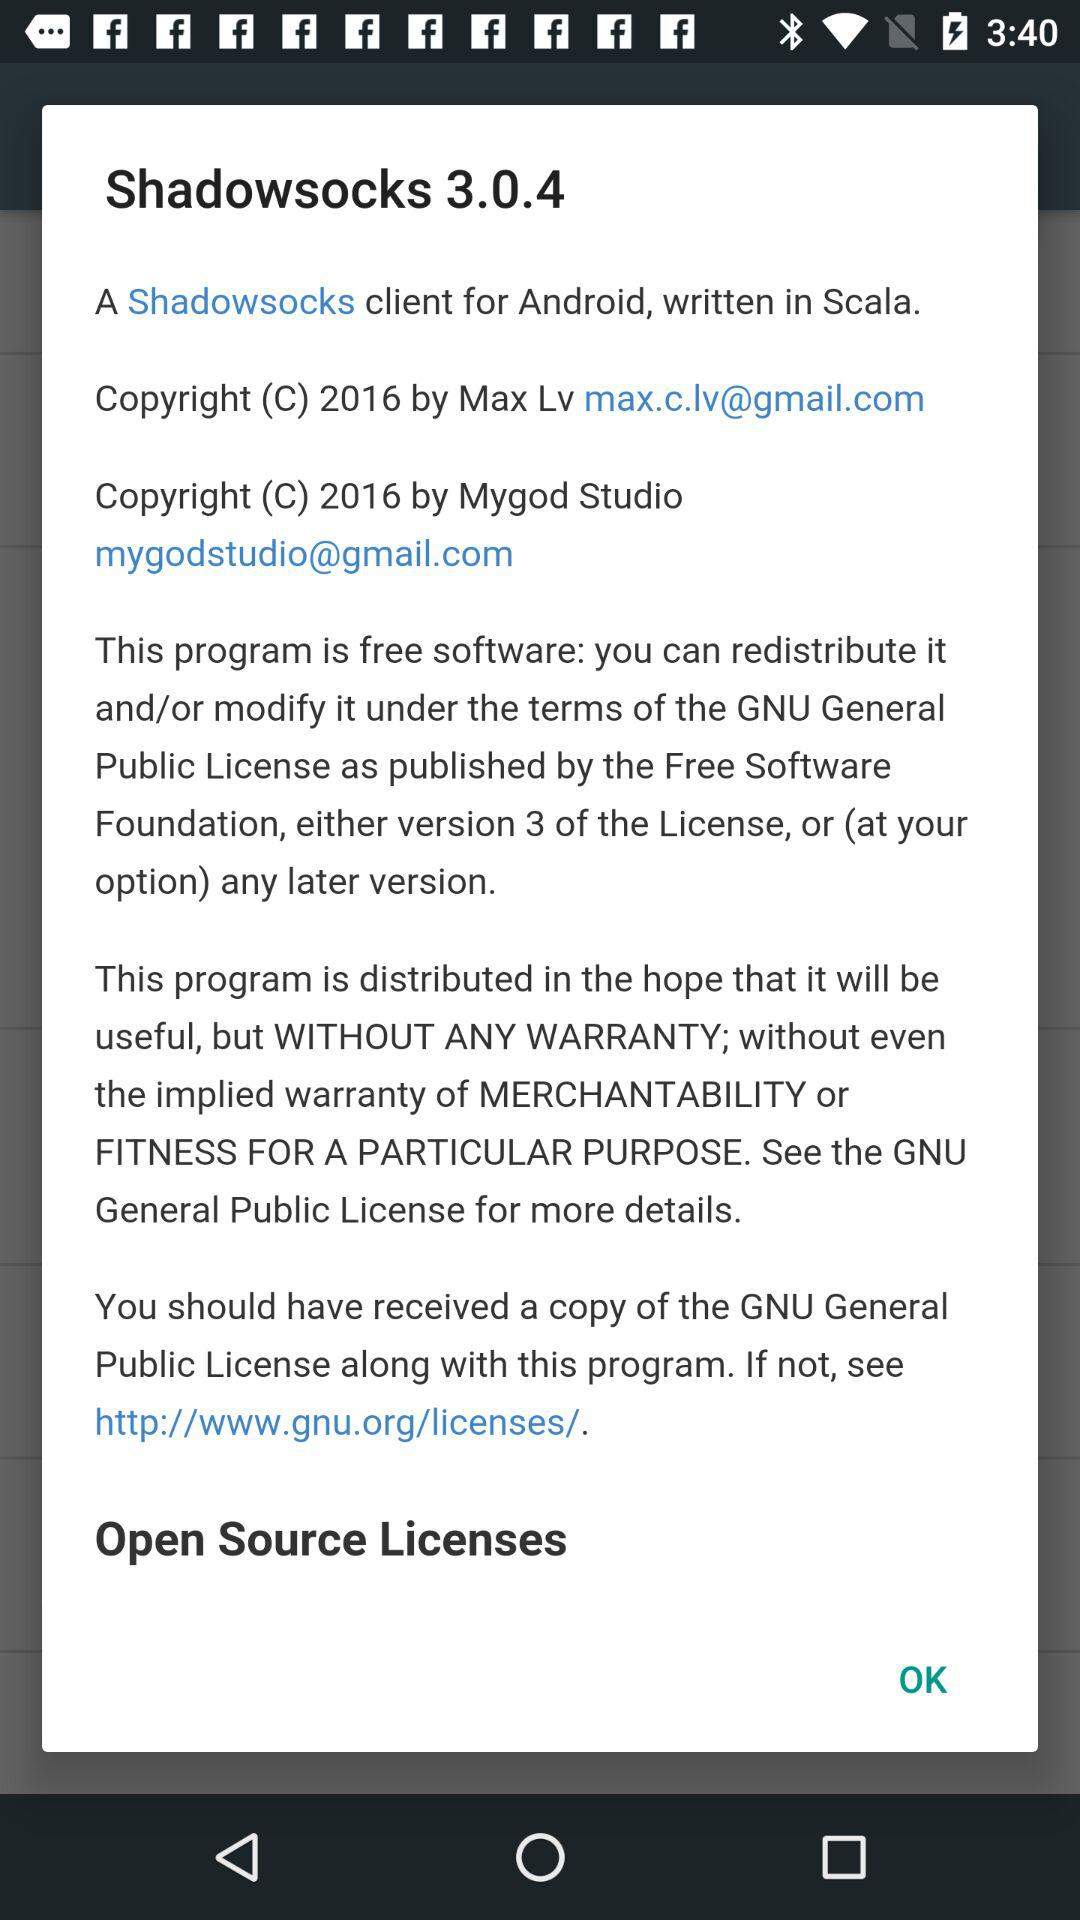How many open source licenses are mentioned?
Answer the question using a single word or phrase. 1 